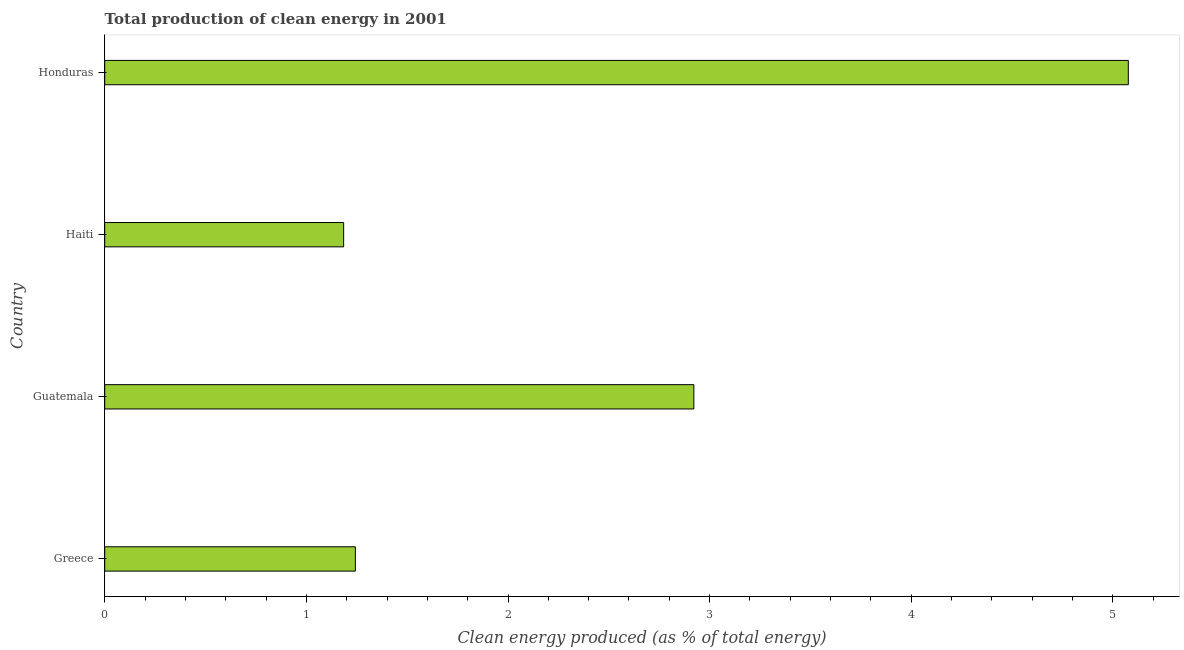Does the graph contain grids?
Keep it short and to the point. No. What is the title of the graph?
Your answer should be compact. Total production of clean energy in 2001. What is the label or title of the X-axis?
Offer a very short reply. Clean energy produced (as % of total energy). What is the label or title of the Y-axis?
Provide a succinct answer. Country. What is the production of clean energy in Guatemala?
Your response must be concise. 2.92. Across all countries, what is the maximum production of clean energy?
Make the answer very short. 5.08. Across all countries, what is the minimum production of clean energy?
Provide a short and direct response. 1.18. In which country was the production of clean energy maximum?
Your answer should be very brief. Honduras. In which country was the production of clean energy minimum?
Make the answer very short. Haiti. What is the sum of the production of clean energy?
Ensure brevity in your answer.  10.43. What is the difference between the production of clean energy in Haiti and Honduras?
Your answer should be compact. -3.89. What is the average production of clean energy per country?
Provide a succinct answer. 2.61. What is the median production of clean energy?
Your answer should be very brief. 2.08. In how many countries, is the production of clean energy greater than 4 %?
Offer a very short reply. 1. What is the ratio of the production of clean energy in Haiti to that in Honduras?
Your response must be concise. 0.23. What is the difference between the highest and the second highest production of clean energy?
Make the answer very short. 2.15. What is the difference between the highest and the lowest production of clean energy?
Provide a succinct answer. 3.89. How many bars are there?
Offer a terse response. 4. Are all the bars in the graph horizontal?
Your response must be concise. Yes. How many countries are there in the graph?
Provide a succinct answer. 4. What is the difference between two consecutive major ticks on the X-axis?
Provide a short and direct response. 1. Are the values on the major ticks of X-axis written in scientific E-notation?
Offer a very short reply. No. What is the Clean energy produced (as % of total energy) in Greece?
Provide a short and direct response. 1.24. What is the Clean energy produced (as % of total energy) in Guatemala?
Your answer should be very brief. 2.92. What is the Clean energy produced (as % of total energy) in Haiti?
Ensure brevity in your answer.  1.18. What is the Clean energy produced (as % of total energy) of Honduras?
Provide a short and direct response. 5.08. What is the difference between the Clean energy produced (as % of total energy) in Greece and Guatemala?
Offer a terse response. -1.68. What is the difference between the Clean energy produced (as % of total energy) in Greece and Haiti?
Ensure brevity in your answer.  0.06. What is the difference between the Clean energy produced (as % of total energy) in Greece and Honduras?
Your answer should be very brief. -3.83. What is the difference between the Clean energy produced (as % of total energy) in Guatemala and Haiti?
Your answer should be very brief. 1.74. What is the difference between the Clean energy produced (as % of total energy) in Guatemala and Honduras?
Offer a terse response. -2.15. What is the difference between the Clean energy produced (as % of total energy) in Haiti and Honduras?
Ensure brevity in your answer.  -3.89. What is the ratio of the Clean energy produced (as % of total energy) in Greece to that in Guatemala?
Offer a terse response. 0.42. What is the ratio of the Clean energy produced (as % of total energy) in Greece to that in Haiti?
Offer a very short reply. 1.05. What is the ratio of the Clean energy produced (as % of total energy) in Greece to that in Honduras?
Your response must be concise. 0.24. What is the ratio of the Clean energy produced (as % of total energy) in Guatemala to that in Haiti?
Give a very brief answer. 2.47. What is the ratio of the Clean energy produced (as % of total energy) in Guatemala to that in Honduras?
Provide a short and direct response. 0.58. What is the ratio of the Clean energy produced (as % of total energy) in Haiti to that in Honduras?
Your answer should be compact. 0.23. 